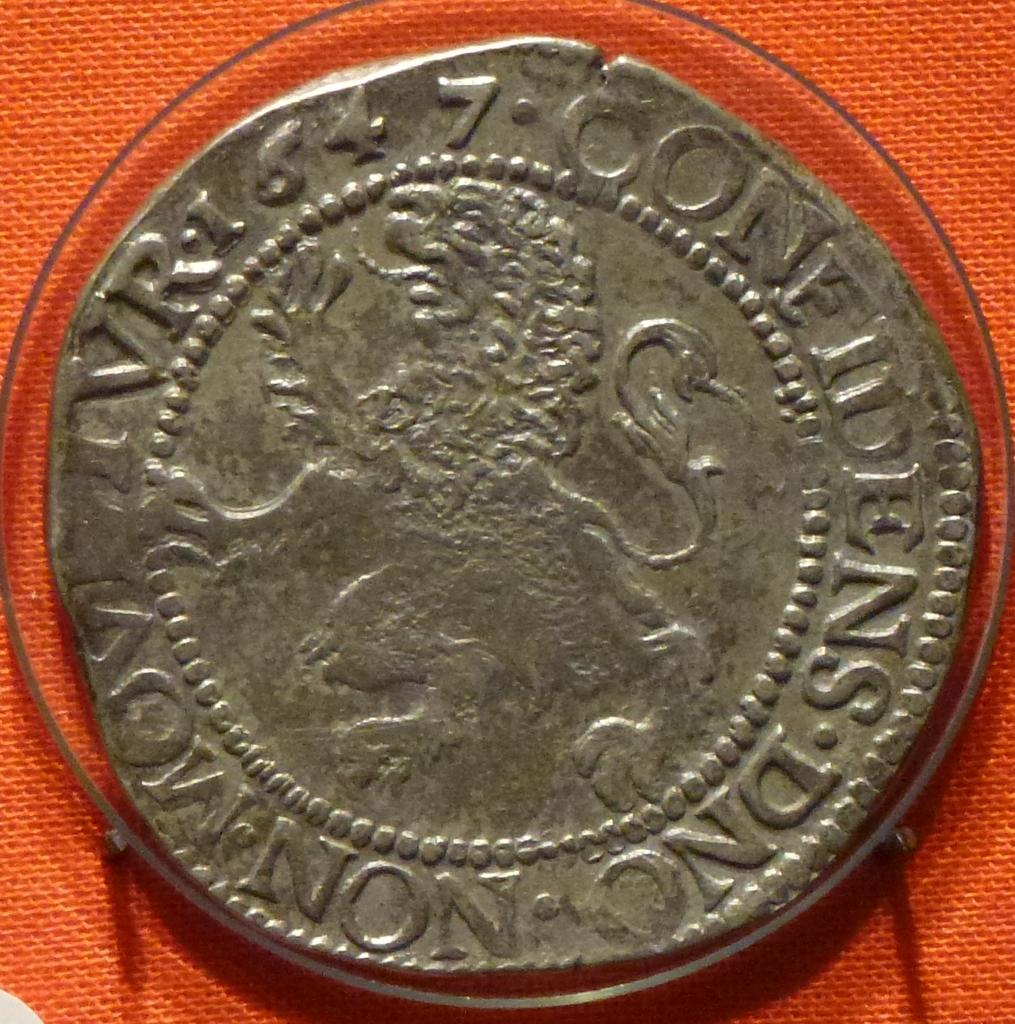<image>
Offer a succinct explanation of the picture presented. An old worn out coin with the letters NS DNC written on one side. 